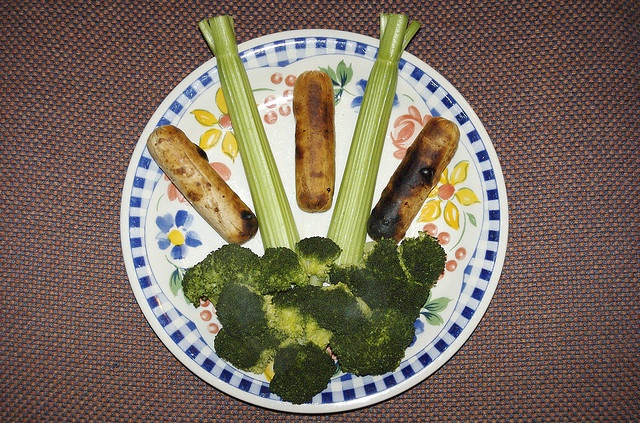Describe the objects in this image and their specific colors. I can see broccoli in purple, black, darkgreen, and olive tones, hot dog in purple, black, olive, and maroon tones, hot dog in purple, olive, and tan tones, and hot dog in purple, olive, and maroon tones in this image. 